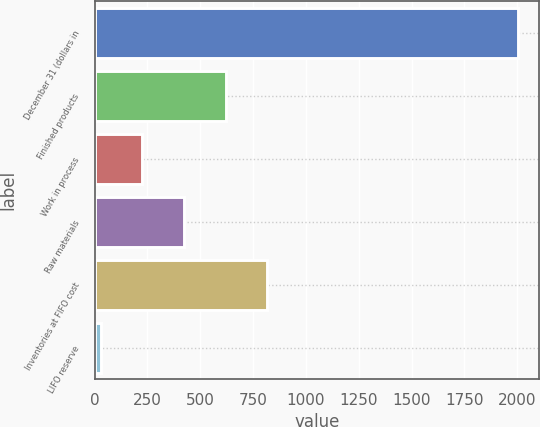<chart> <loc_0><loc_0><loc_500><loc_500><bar_chart><fcel>December 31 (dollars in<fcel>Finished products<fcel>Work in process<fcel>Raw materials<fcel>Inventories at FIFO cost<fcel>LIFO reserve<nl><fcel>2002<fcel>620.41<fcel>225.67<fcel>423.04<fcel>817.78<fcel>28.3<nl></chart> 